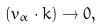<formula> <loc_0><loc_0><loc_500><loc_500>( v _ { \alpha } \cdot k ) \rightarrow 0 ,</formula> 